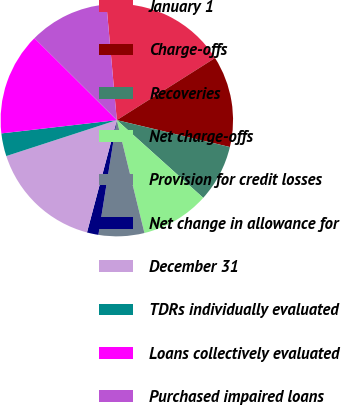Convert chart to OTSL. <chart><loc_0><loc_0><loc_500><loc_500><pie_chart><fcel>January 1<fcel>Charge-offs<fcel>Recoveries<fcel>Net charge-offs<fcel>Provision for credit losses<fcel>Net change in allowance for<fcel>December 31<fcel>TDRs individually evaluated<fcel>Loans collectively evaluated<fcel>Purchased impaired loans<nl><fcel>17.45%<fcel>12.69%<fcel>7.94%<fcel>9.52%<fcel>6.35%<fcel>1.6%<fcel>15.86%<fcel>3.18%<fcel>14.28%<fcel>11.11%<nl></chart> 